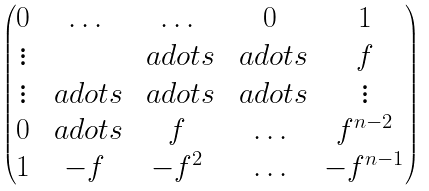Convert formula to latex. <formula><loc_0><loc_0><loc_500><loc_500>\begin{pmatrix} 0 & \hdots & \hdots & 0 & 1 \\ \vdots & & \ a d o t s & \ a d o t s & f \\ \vdots & \ a d o t s & \ a d o t s & \ a d o t s & \vdots \\ 0 & \ a d o t s & f & \hdots & f ^ { n - 2 } \\ 1 & - f & - f ^ { 2 } & \hdots & - f ^ { n - 1 } \end{pmatrix}</formula> 